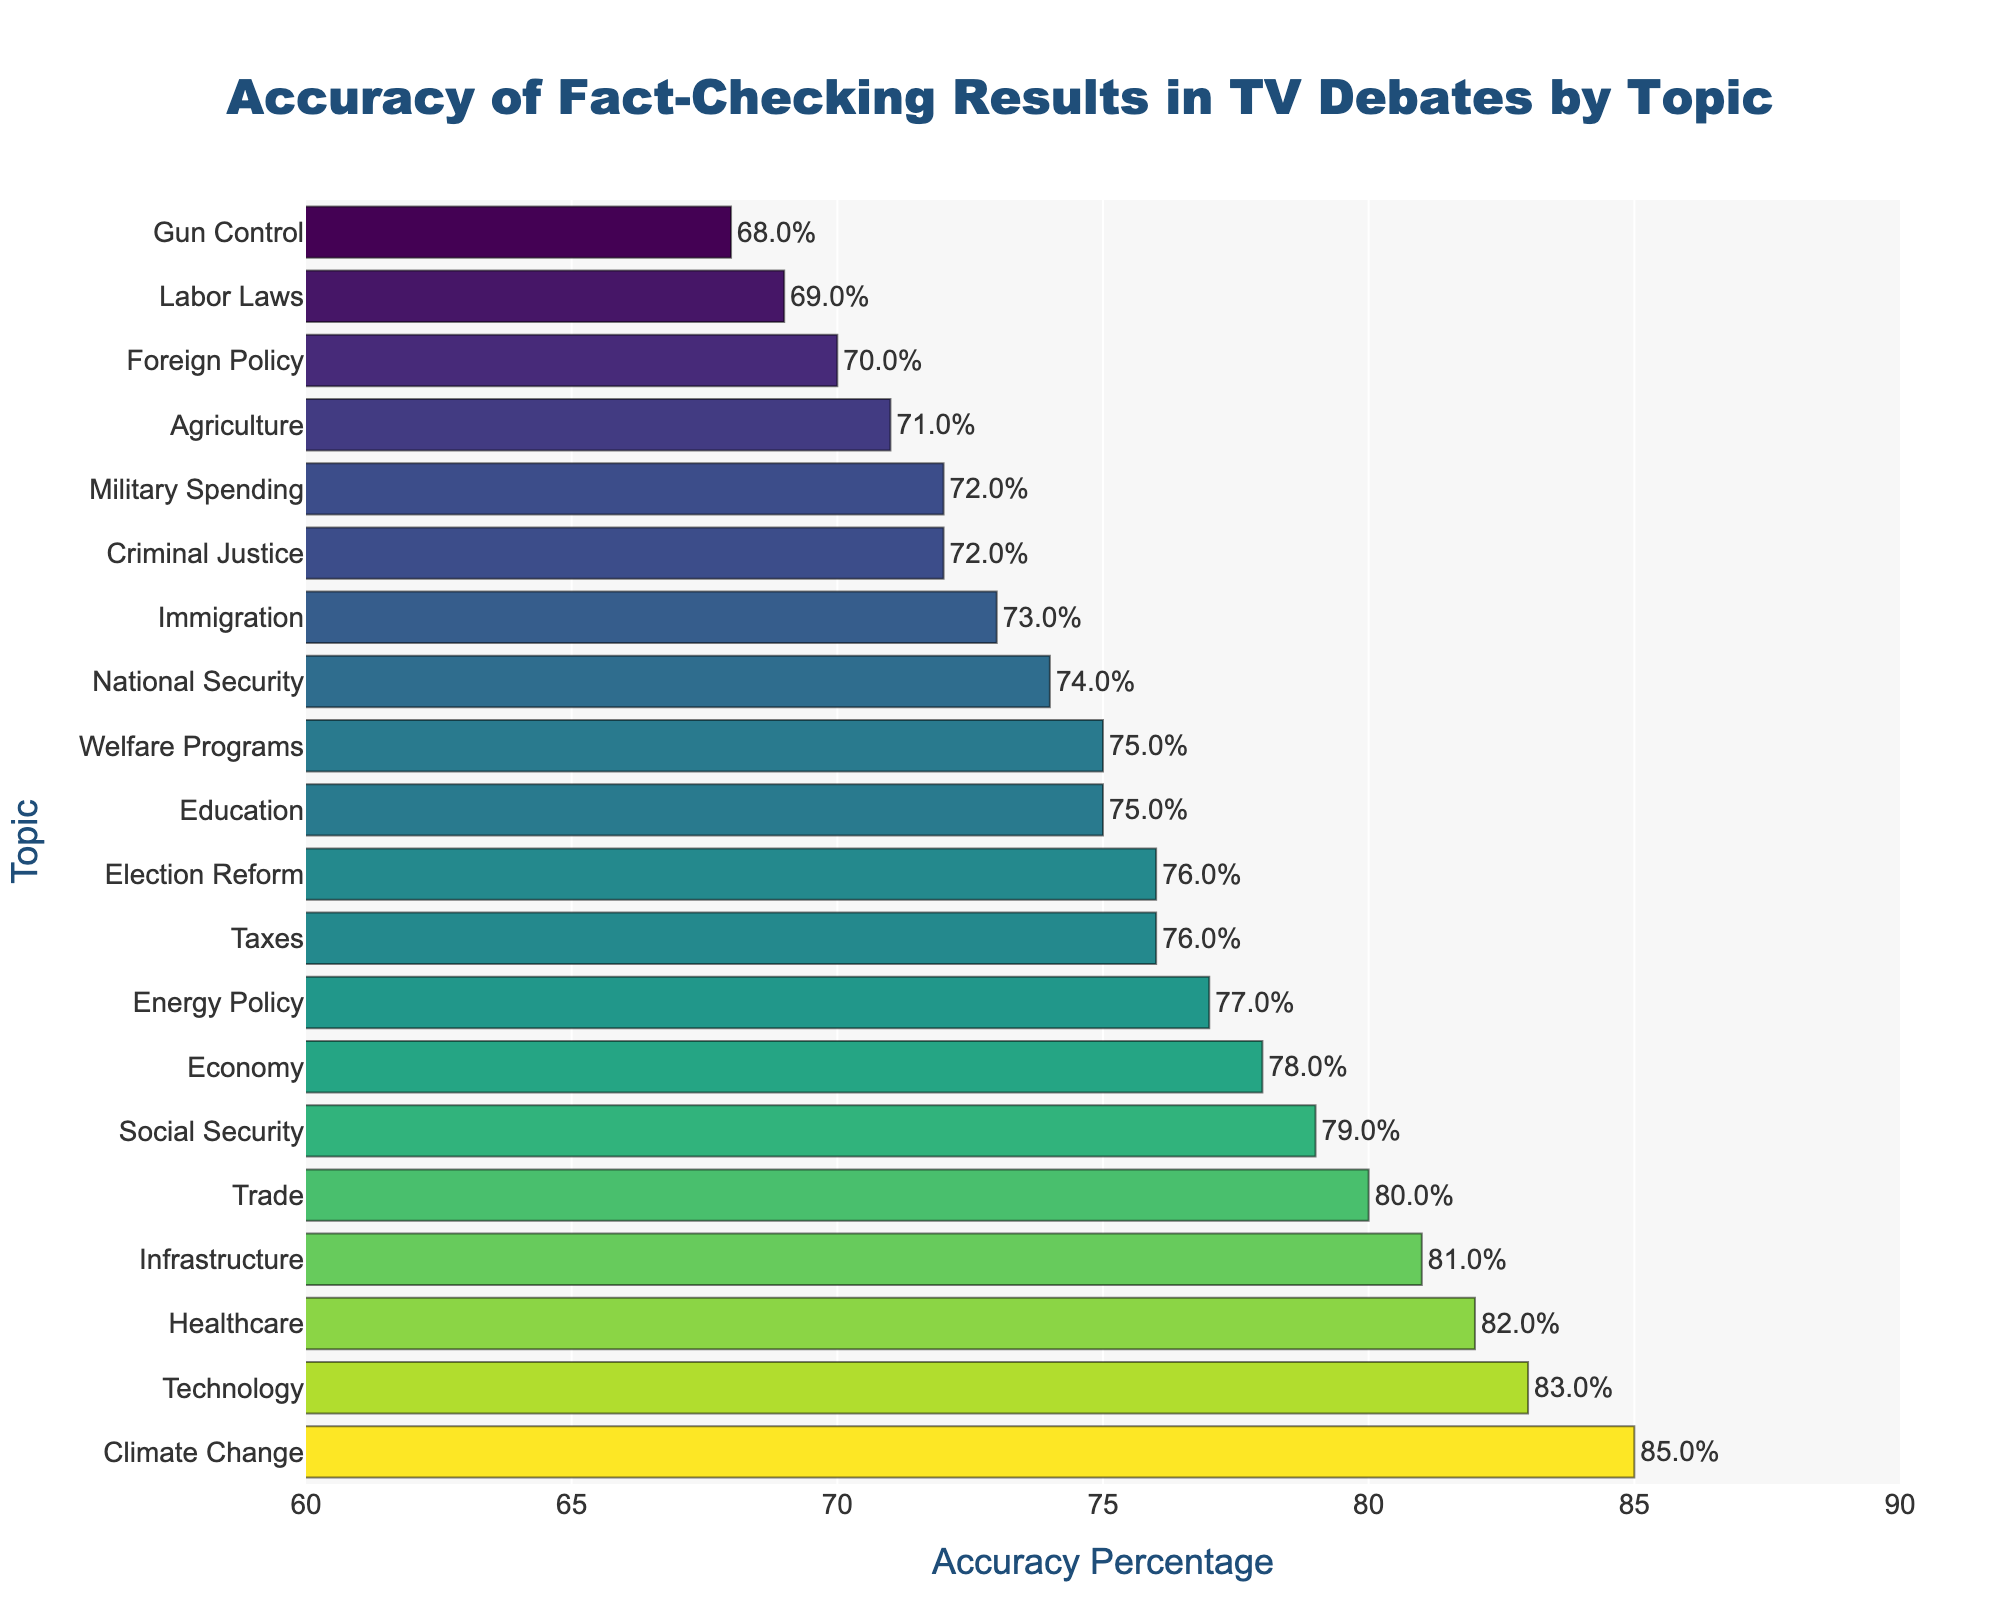What topic has the highest accuracy percentage in fact-checking? Look at the bar with the highest value, which is 85%. The label next to this bar indicates the topic is "Climate Change".
Answer: Climate Change Which two topics have equal or nearly equal accuracy percentages? Compare the lengths of the bars to find bars of equal length. The bars for Taxes and Election Reform both have an accuracy percentage of 76%.
Answer: Taxes and Election Reform How many topics have an accuracy percentage of 80% or higher? Count the number of bars that extend to 80% or more. The topics are Climate Change, Healthcare, Technology, Trade, Social Security, and Infrastructure. So there are 6 topics.
Answer: 6 What's the accuracy percentage difference between Health care and Gun Control? Locate the bars for Healthcare (82%) and Gun Control (68%) and subtract the lower accuracy from the higher one: 82% - 68% = 14%.
Answer: 14% Which topic has the least accuracy percentage, and what is the value? Find the shortest bar on the chart. The shortest bar is for Gun Control with an accuracy percentage of 68%.
Answer: Gun Control, 68% What is the average accuracy percentage for the three topics with the highest accuracy? Identify the three highest bars: Climate Change (85%), Healthcare (82%), and Technology (83%). Calculate the average: (85 + 82 + 83) / 3 = 83.3%.
Answer: 83.3% Which topics have an accuracy percentage between 70% and 75%? Identify the bars that fall within this range: Education (75%), Criminal Justice (72%), Agriculture (71%), and Labor Laws (69%) if rounding.
Answer: Education, Criminal Justice, and Agriculture What is the difference in accuracy percentage between Foreign Policy and Immigration? Locate the bars for Foreign Policy (70%) and Immigration (73%) and subtract the lower percentage from the higher one: 73% - 70% = 3%.
Answer: 3% Is the bar for Healthcare longer than the bar for National Security? Compare the lengths of the bars for Healthcare (82%) and National Security (74%). Since 82% is greater than 74%, the bar for Healthcare is longer.
Answer: Yes 